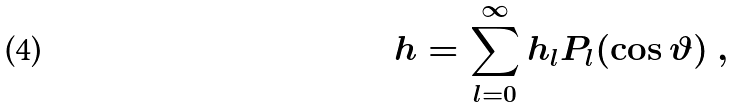<formula> <loc_0><loc_0><loc_500><loc_500>h = \sum _ { l = 0 } ^ { \infty } h _ { l } P _ { l } ( \cos \vartheta ) \ ,</formula> 